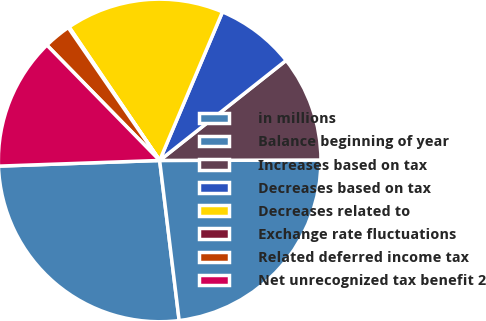Convert chart to OTSL. <chart><loc_0><loc_0><loc_500><loc_500><pie_chart><fcel>in millions<fcel>Balance beginning of year<fcel>Increases based on tax<fcel>Decreases based on tax<fcel>Decreases related to<fcel>Exchange rate fluctuations<fcel>Related deferred income tax<fcel>Net unrecognized tax benefit 2<nl><fcel>26.37%<fcel>23.11%<fcel>10.61%<fcel>7.98%<fcel>15.86%<fcel>0.1%<fcel>2.73%<fcel>13.24%<nl></chart> 